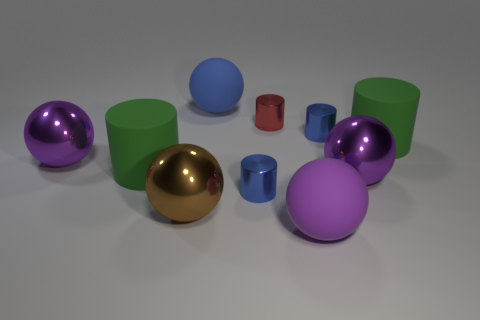How many purple spheres must be subtracted to get 1 purple spheres? 2 Subtract all cyan cubes. How many purple spheres are left? 3 Subtract all blue spheres. How many spheres are left? 4 Subtract all brown balls. How many balls are left? 4 Subtract all purple cylinders. Subtract all cyan blocks. How many cylinders are left? 5 Add 3 cylinders. How many cylinders are left? 8 Add 9 large blue things. How many large blue things exist? 10 Subtract 2 green cylinders. How many objects are left? 8 Subtract all big blue matte spheres. Subtract all brown metallic things. How many objects are left? 8 